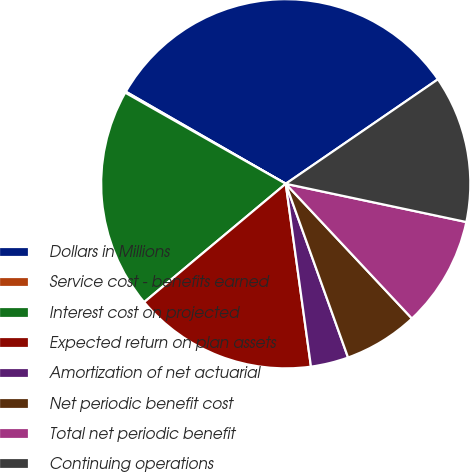<chart> <loc_0><loc_0><loc_500><loc_500><pie_chart><fcel>Dollars in Millions<fcel>Service cost - benefits earned<fcel>Interest cost on projected<fcel>Expected return on plan assets<fcel>Amortization of net actuarial<fcel>Net periodic benefit cost<fcel>Total net periodic benefit<fcel>Continuing operations<nl><fcel>32.11%<fcel>0.1%<fcel>19.3%<fcel>16.1%<fcel>3.3%<fcel>6.5%<fcel>9.7%<fcel>12.9%<nl></chart> 